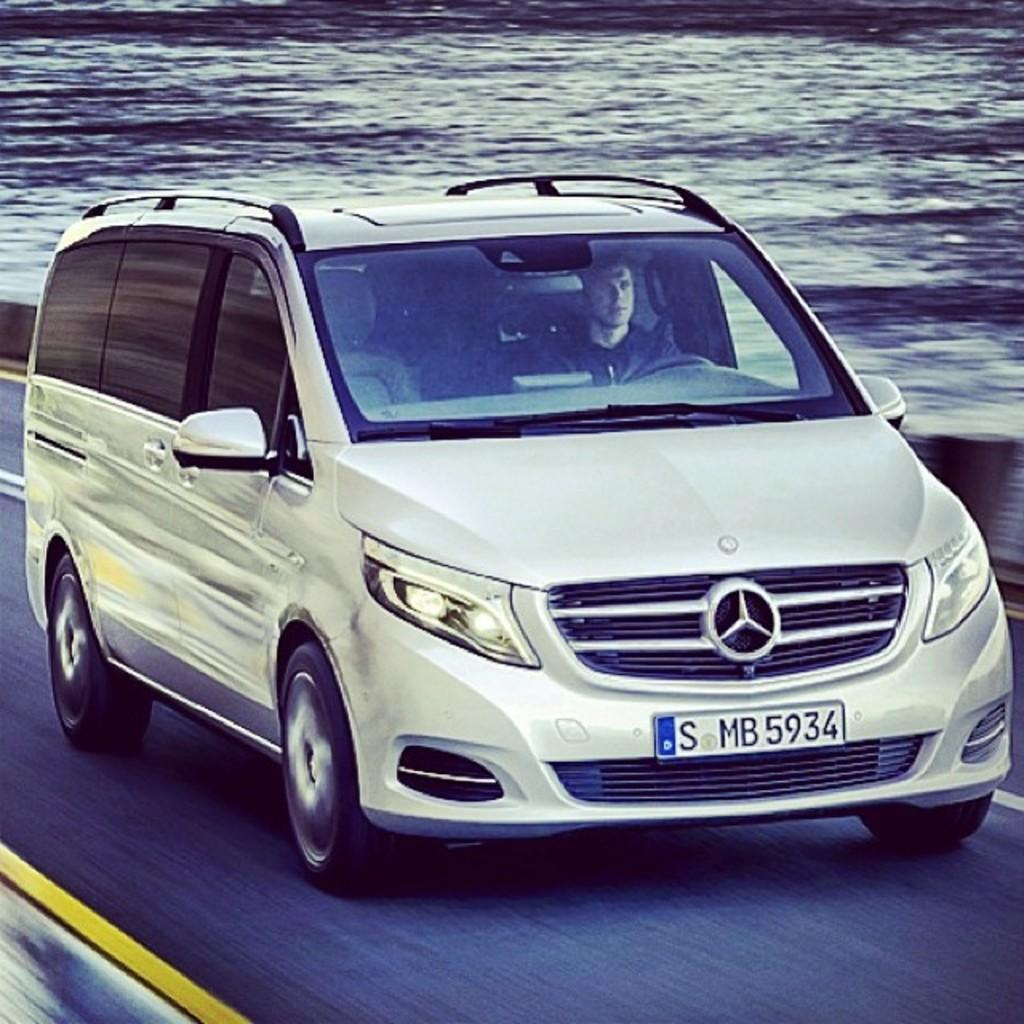<image>
Write a terse but informative summary of the picture. A minivan with a foreign licence plate that reads S MB5934. 